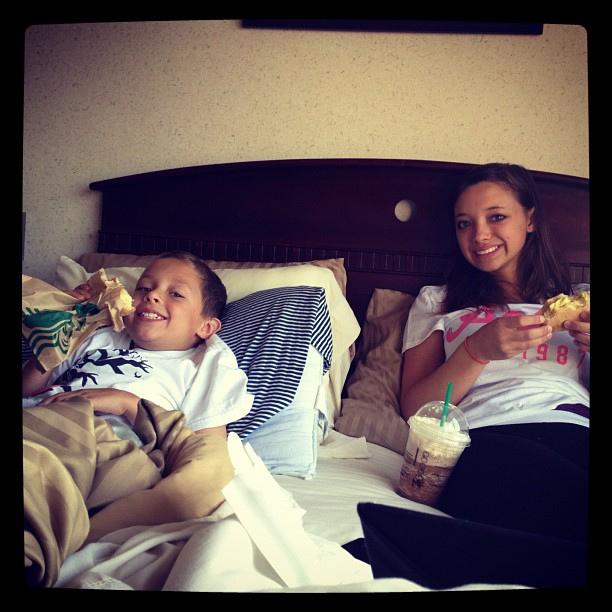What is the girl eating?
Keep it brief. Sandwich. Is the boy traveling somewhere?
Answer briefly. No. Does this boy have glasses?
Be succinct. No. What are the people looking at?
Quick response, please. Camera. Is the boy digging in his nose?
Be succinct. No. Is this photo old?
Be succinct. No. What are these people doing?
Short answer required. Eating. Is the bed made or a mess?
Answer briefly. Mess. 